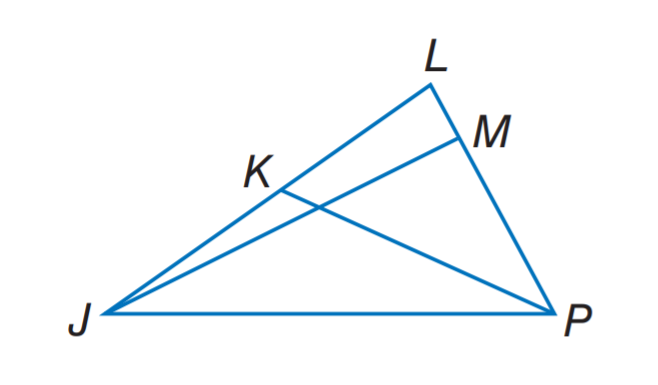Question: In \triangle J L P, m \angle J M P = 3 x - 6, J K = 3 y - 2, and L K = 5 y - 8. If J M is an altitude of \triangle J L P, find x.
Choices:
A. 23
B. 32
C. 35
D. 55
Answer with the letter. Answer: B Question: In \triangle J L P, m \angle J M P = 3 x - 6, J K = 3 y - 2, and L K = 5 y - 8. Find L K if P K is a median.
Choices:
A. 2
B. 5
C. 7
D. 8
Answer with the letter. Answer: C 